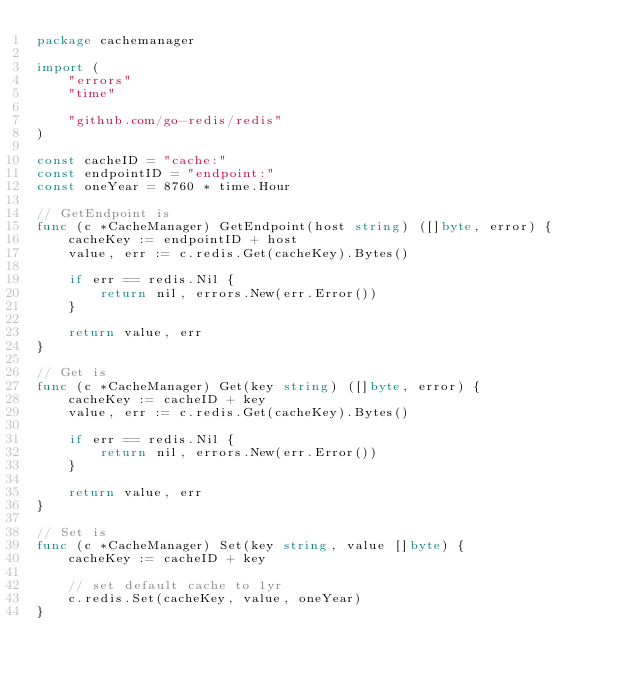<code> <loc_0><loc_0><loc_500><loc_500><_Go_>package cachemanager

import (
	"errors"
	"time"

	"github.com/go-redis/redis"
)

const cacheID = "cache:"
const endpointID = "endpoint:"
const oneYear = 8760 * time.Hour

// GetEndpoint is
func (c *CacheManager) GetEndpoint(host string) ([]byte, error) {
	cacheKey := endpointID + host
	value, err := c.redis.Get(cacheKey).Bytes()

	if err == redis.Nil {
		return nil, errors.New(err.Error())
	}

	return value, err
}

// Get is
func (c *CacheManager) Get(key string) ([]byte, error) {
	cacheKey := cacheID + key
	value, err := c.redis.Get(cacheKey).Bytes()

	if err == redis.Nil {
		return nil, errors.New(err.Error())
	}

	return value, err
}

// Set is
func (c *CacheManager) Set(key string, value []byte) {
	cacheKey := cacheID + key

	// set default cache to 1yr
	c.redis.Set(cacheKey, value, oneYear)
}
</code> 